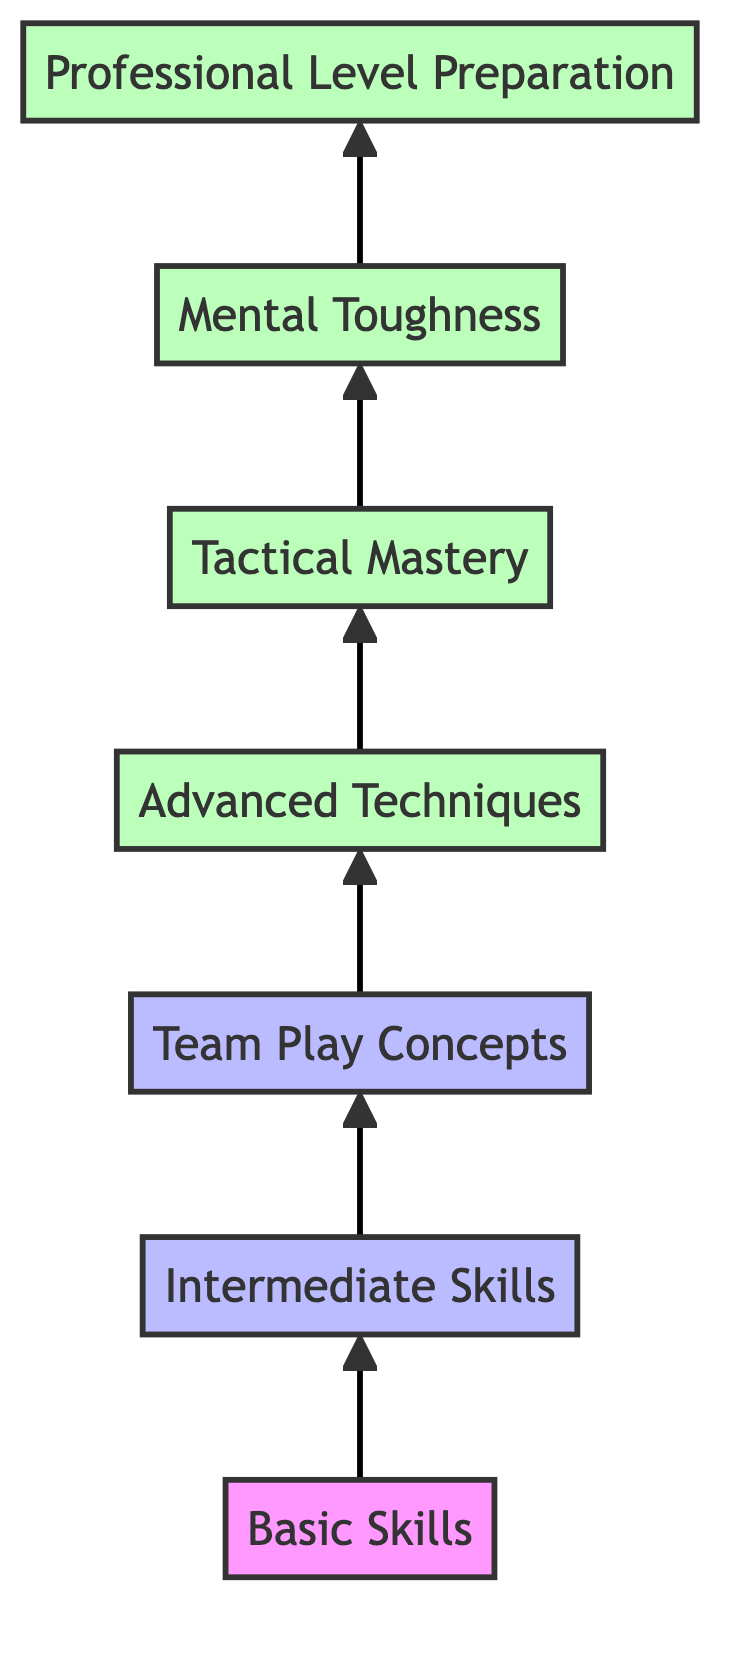What is the first level in the flow chart? The flow chart begins with "Basic Skills" as the first level. We can identify this by observing the bottommost node in the diagram.
Answer: Basic Skills How many total levels are there in the flow chart? Counting from the bottom to the top, there are seven levels in the diagram: Basic Skills, Intermediate Skills, Team Play Concepts, Advanced Techniques, Tactical Mastery, Mental Toughness, and Professional Level Preparation.
Answer: 7 What is the last skill before reaching professional level preparation? The last skill before reaching "Professional Level Preparation" is "Mental Toughness." This can be determined by tracing the path from the bottom to the top and identifying the node directly preceding the final one.
Answer: Mental Toughness Which level focuses on teamwork and coordination? The level that focuses on teamwork and coordination is "Team Play Concepts." This is indicated by the description in that node.
Answer: Team Play Concepts What are the three advanced techniques mentioned in the diagram? The advanced techniques mentioned include "Curling shots," "Precision passing," and "High-speed dribbling." These examples are listed under the "Advanced Techniques" node.
Answer: Curling shots, Precision passing, High-speed dribbling How does "Tactical Mastery" relate to "Advanced Techniques"? "Tactical Mastery" comes directly after "Advanced Techniques" in the flow chart, indicating that it follows as a more advanced understanding of the skills taught before it. This is a direct relationship in the progression of skills.
Answer: It follows directly What type of skills are developed in the second level? The second level features "Intermediate Skills," which develop enhanced techniques and tactical awareness. This is derived from the description provided in that node.
Answer: Intermediate Skills What is the progression from basic skills to advanced techniques? The progression starts at "Basic Skills," then moves to "Intermediate Skills," followed by "Team Play Concepts," and finally reaches "Advanced Techniques." This flow shows the upward progression of skill levels in the diagram.
Answer: Basic Skills to Intermediate Skills to Team Play Concepts to Advanced Techniques 